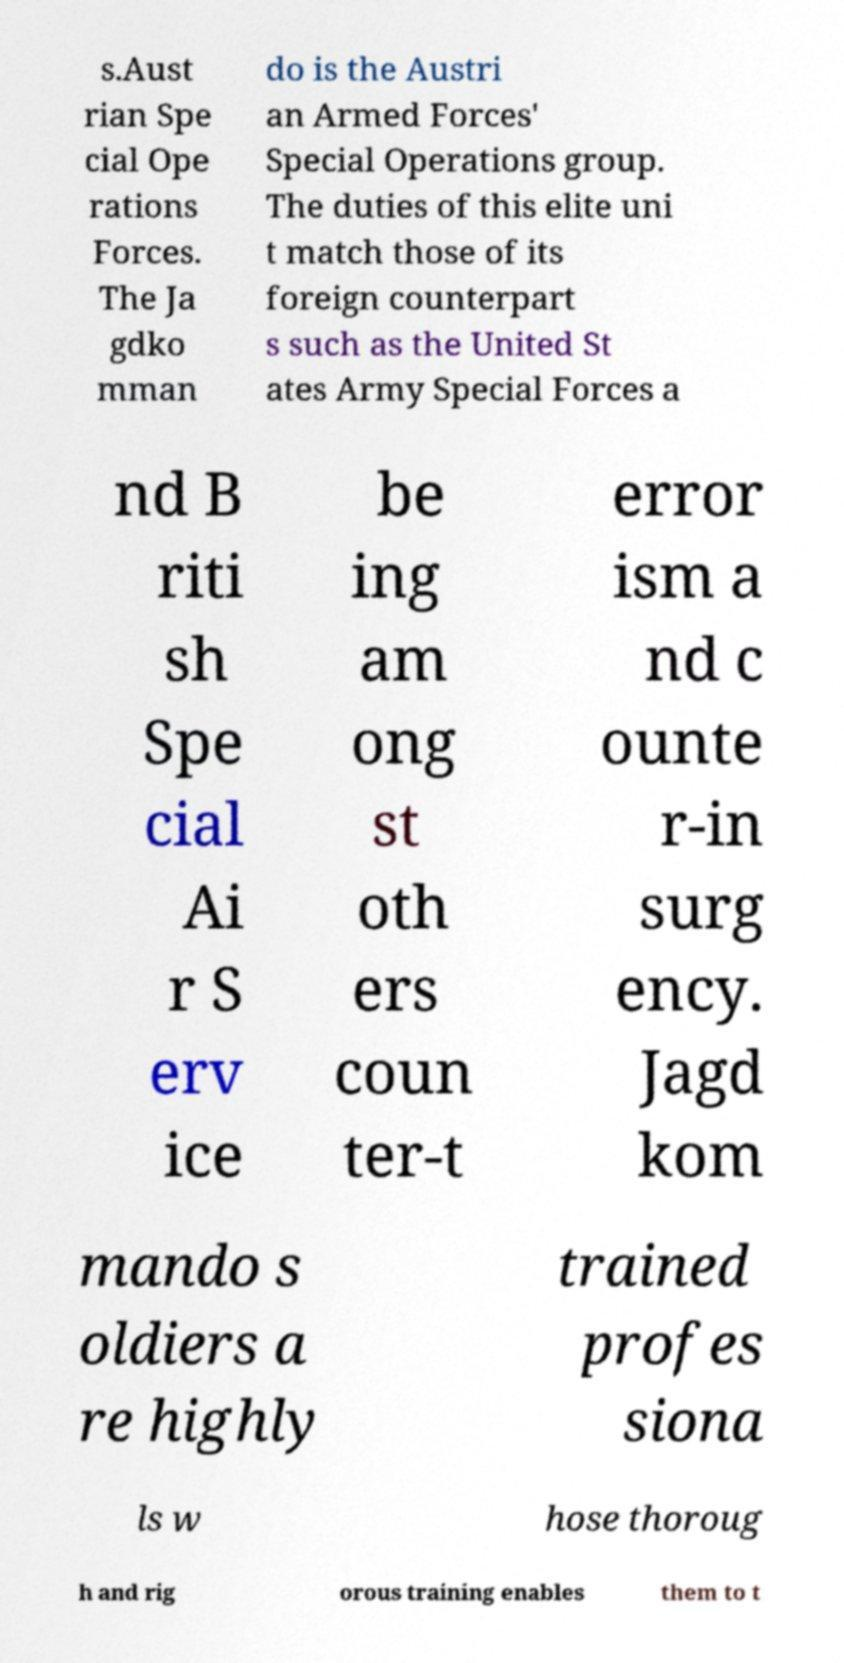For documentation purposes, I need the text within this image transcribed. Could you provide that? s.Aust rian Spe cial Ope rations Forces. The Ja gdko mman do is the Austri an Armed Forces' Special Operations group. The duties of this elite uni t match those of its foreign counterpart s such as the United St ates Army Special Forces a nd B riti sh Spe cial Ai r S erv ice be ing am ong st oth ers coun ter-t error ism a nd c ounte r-in surg ency. Jagd kom mando s oldiers a re highly trained profes siona ls w hose thoroug h and rig orous training enables them to t 